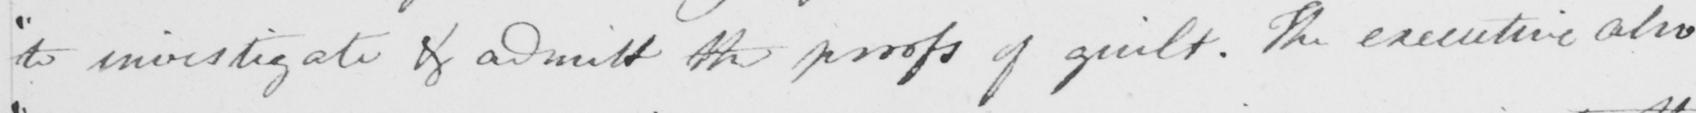What does this handwritten line say? " to investigate & and admit the proofs of guilt . The executive also 